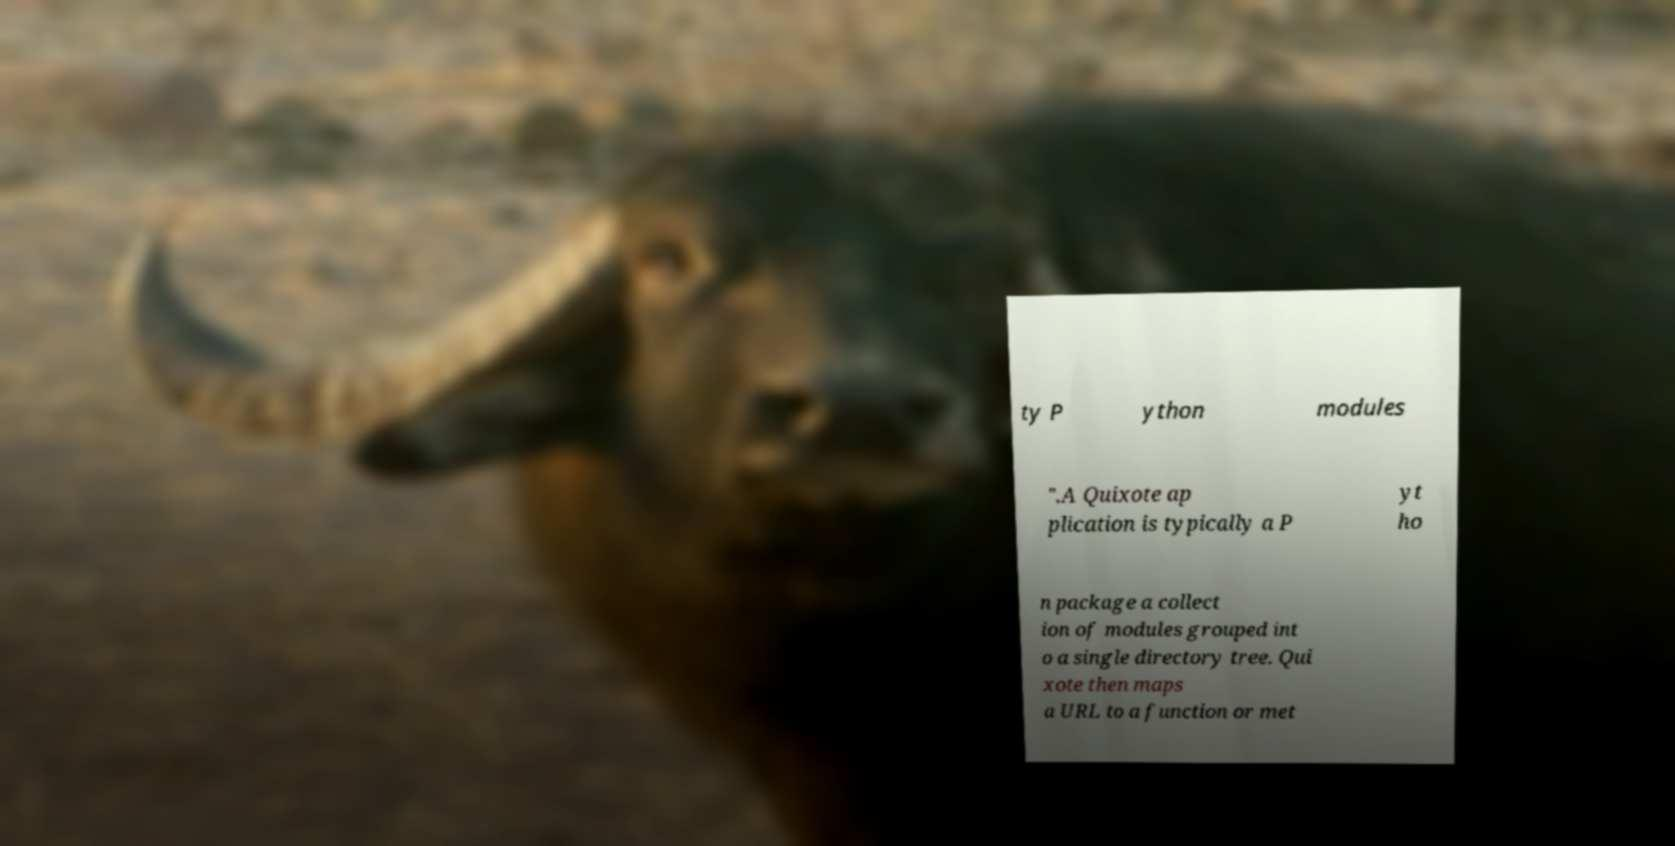Can you accurately transcribe the text from the provided image for me? ty P ython modules ".A Quixote ap plication is typically a P yt ho n package a collect ion of modules grouped int o a single directory tree. Qui xote then maps a URL to a function or met 